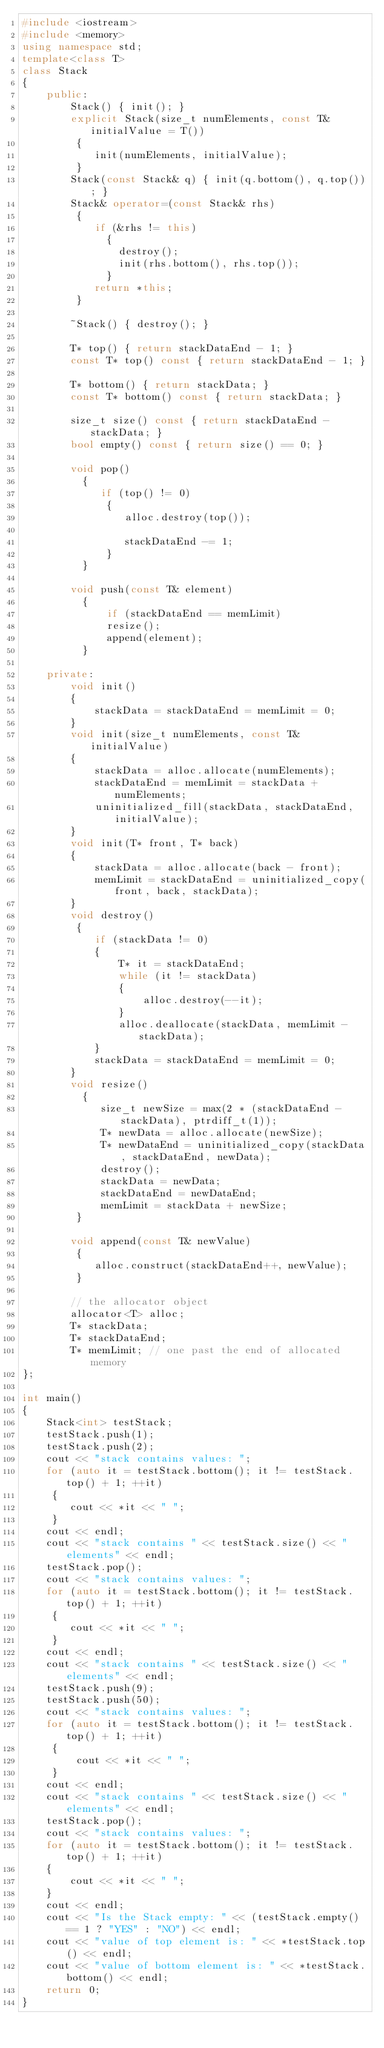<code> <loc_0><loc_0><loc_500><loc_500><_C++_>#include <iostream>
#include <memory>
using namespace std;
template<class T>   
class Stack   
{   
    public:   
        Stack() { init(); } 
        explicit Stack(size_t numElements, const T& initialValue = T()) 
         {  
            init(numElements, initialValue); 
         } 
        Stack(const Stack& q) { init(q.bottom(), q.top()); }
        Stack& operator=(const Stack& rhs)
         {
            if (&rhs != this)
              {
                destroy();
                init(rhs.bottom(), rhs.top());
              }
            return *this;
         }

        ~Stack() { destroy(); }
 
        T* top() { return stackDataEnd - 1; }  
        const T* top() const { return stackDataEnd - 1; }  
         
        T* bottom() { return stackData; }  
        const T* bottom() const { return stackData; }  
         
        size_t size() const { return stackDataEnd - stackData; }  
        bool empty() const { return size() == 0; } 
        
        void pop()
          {
             if (top() != 0)
              {
                 alloc.destroy(top());
 
                 stackDataEnd -= 1;
              }
          }
        
        void push(const T& element)
          {
              if (stackDataEnd == memLimit)
              resize();
              append(element);
          }
 
    private:  
        void init()
        {
            stackData = stackDataEnd = memLimit = 0;
        }
        void init(size_t numElements, const T& initialValue)
        {
            stackData = alloc.allocate(numElements);
            stackDataEnd = memLimit = stackData + numElements;
            uninitialized_fill(stackData, stackDataEnd, initialValue);
        }
        void init(T* front, T* back)
        {
            stackData = alloc.allocate(back - front);
            memLimit = stackDataEnd = uninitialized_copy(front, back, stackData);
        }
        void destroy()
         {
            if (stackData != 0)
            {
                T* it = stackDataEnd;
                while (it != stackData)
                { 
                    alloc.destroy(--it);
                }
                alloc.deallocate(stackData, memLimit - stackData);
            }
            stackData = stackDataEnd = memLimit = 0;
        }        
        void resize()
          {
             size_t newSize = max(2 * (stackDataEnd - stackData), ptrdiff_t(1));
             T* newData = alloc.allocate(newSize);
             T* newDataEnd = uninitialized_copy(stackData, stackDataEnd, newData);
             destroy();
             stackData = newData;
             stackDataEnd = newDataEnd;
             memLimit = stackData + newSize;
         }
 
        void append(const T& newValue)
         {
            alloc.construct(stackDataEnd++, newValue);
         }
        
        // the allocator object
        allocator<T> alloc;
        T* stackData;  
        T* stackDataEnd;
        T* memLimit; // one past the end of allocated memory
};

int main()
{
    Stack<int> testStack;
    testStack.push(1);
    testStack.push(2);
    cout << "stack contains values: ";
    for (auto it = testStack.bottom(); it != testStack.top() + 1; ++it)
     {
        cout << *it << " ";
     }
    cout << endl;
    cout << "stack contains " << testStack.size() << " elements" << endl;
    testStack.pop();
    cout << "stack contains values: ";
    for (auto it = testStack.bottom(); it != testStack.top() + 1; ++it)
     {
        cout << *it << " ";
     }
    cout << endl;
    cout << "stack contains " << testStack.size() << " elements" << endl;
    testStack.push(9);
    testStack.push(50);
    cout << "stack contains values: ";
    for (auto it = testStack.bottom(); it != testStack.top() + 1; ++it)
     {
         cout << *it << " ";
     }
    cout << endl;
    cout << "stack contains " << testStack.size() << " elements" << endl;
    testStack.pop();
    cout << "stack contains values: ";
    for (auto it = testStack.bottom(); it != testStack.top() + 1; ++it)
    {
        cout << *it << " ";
    }
    cout << endl;
    cout << "Is the Stack empty: " << (testStack.empty() == 1 ? "YES" : "NO") << endl;
    cout << "value of top element is: " << *testStack.top() << endl;
    cout << "value of bottom element is: " << *testStack.bottom() << endl;
    return 0;
}
</code> 